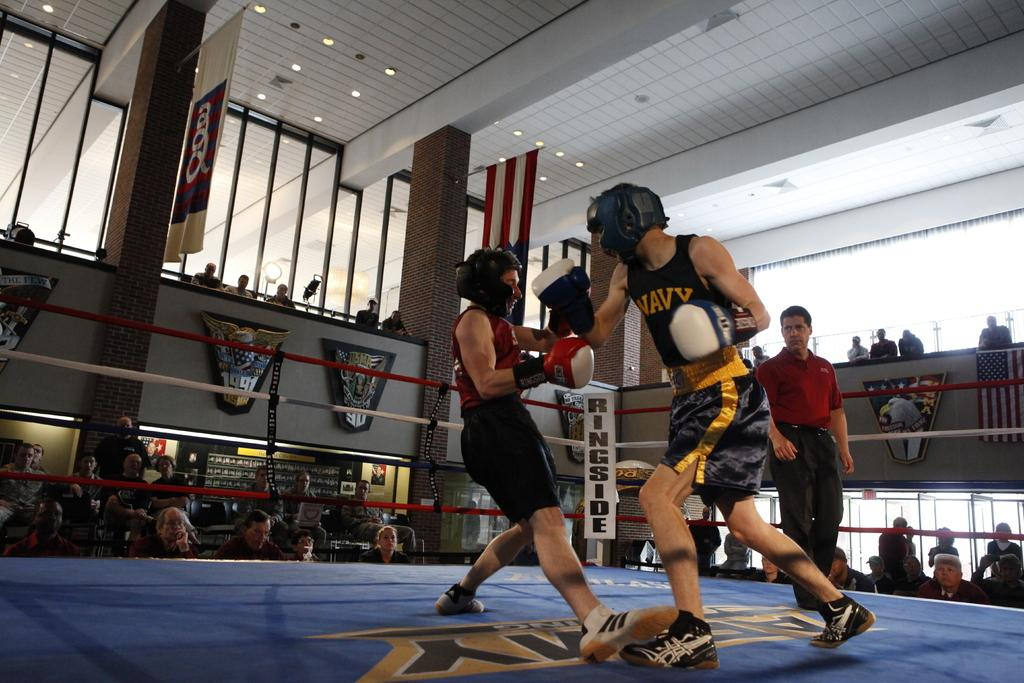Provide a one-sentence caption for the provided image. A man in a navy tank top is in a boxing match. 